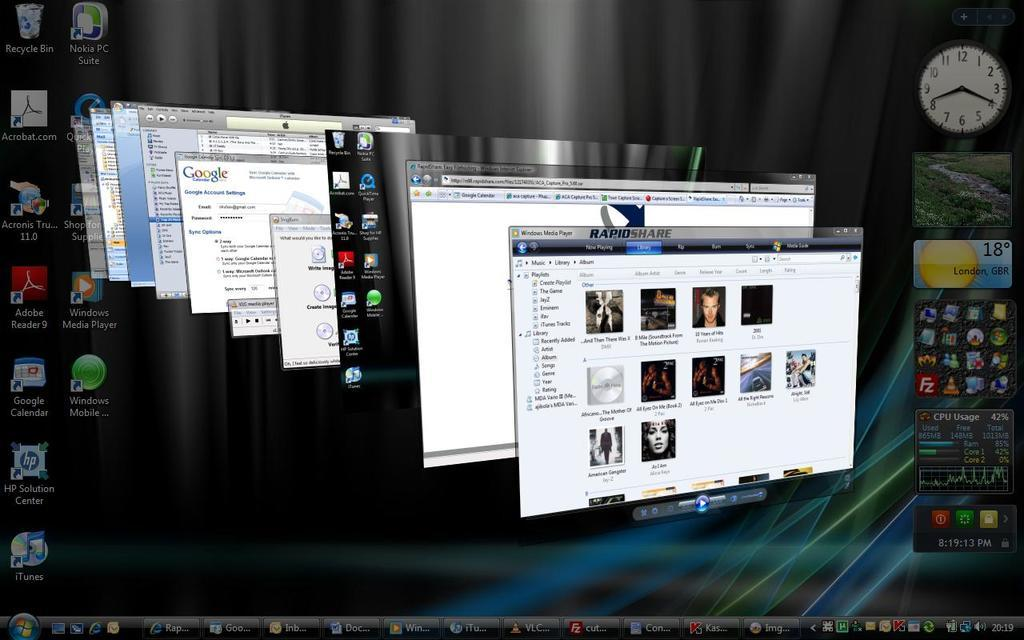Provide a one-sentence caption for the provided image. A computer with many open windows has the RapidShare window on top of the others. 